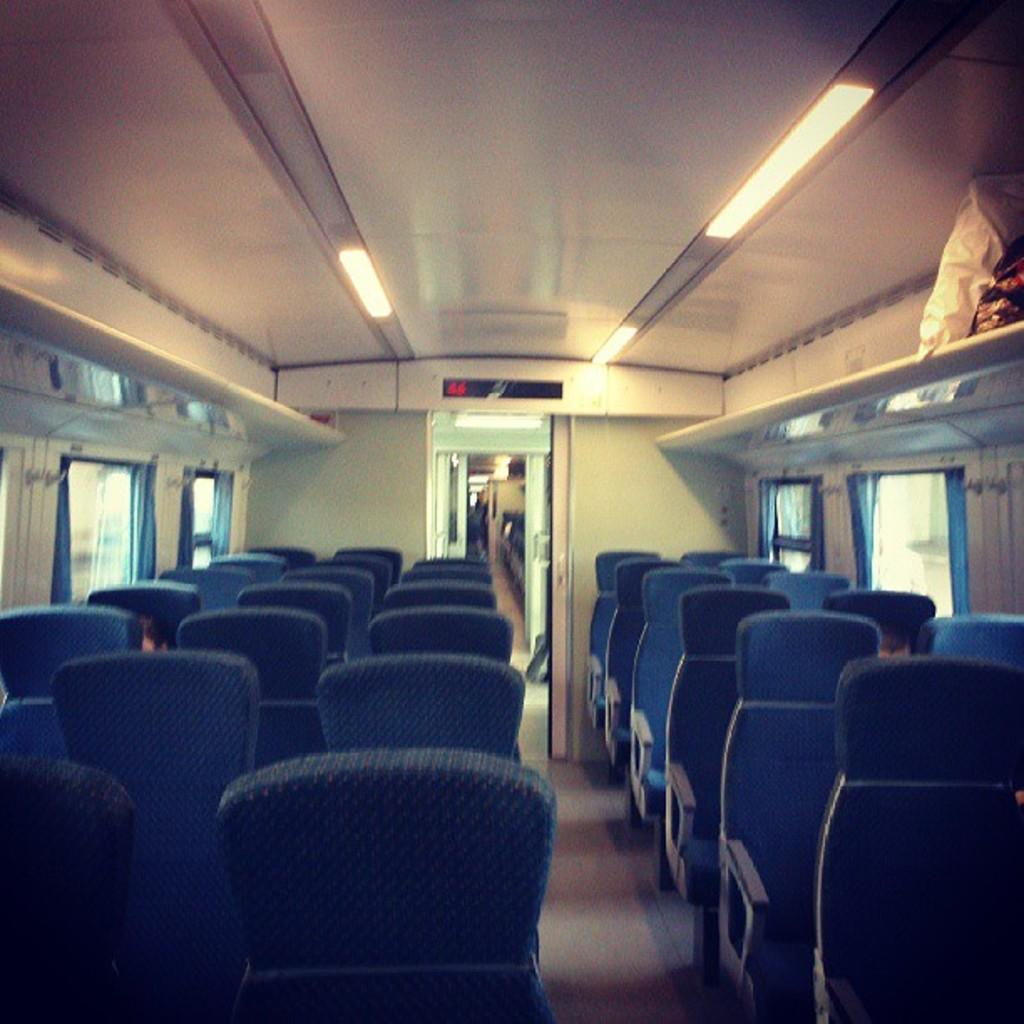What type of vehicle is shown in the image? The image is an inside view of a bus. What can be found at the bottom of the image? There are seats at the bottom of the image. What is located at the top of the image? There are lights at the top of the image. What is visible in the background of the image? There are windows and a door in the background of the image. What word is written on the dolls in the image? There are no dolls present in the image, so it is not possible to determine what word might be written on them. 